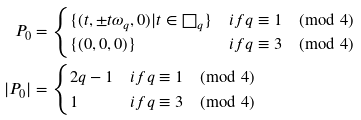<formula> <loc_0><loc_0><loc_500><loc_500>P _ { 0 } & = \begin{cases} \{ ( t , \pm t \omega _ { q } , 0 ) | t \in \square _ { q } \} & i f q \equiv 1 \pmod { 4 } \\ \{ ( 0 , 0 , 0 ) \} & i f q \equiv 3 \pmod { 4 } \end{cases} \\ | P _ { 0 } | & = \begin{cases} 2 q - 1 & i f q \equiv 1 \pmod { 4 } \\ 1 & i f q \equiv 3 \pmod { 4 } \end{cases}</formula> 